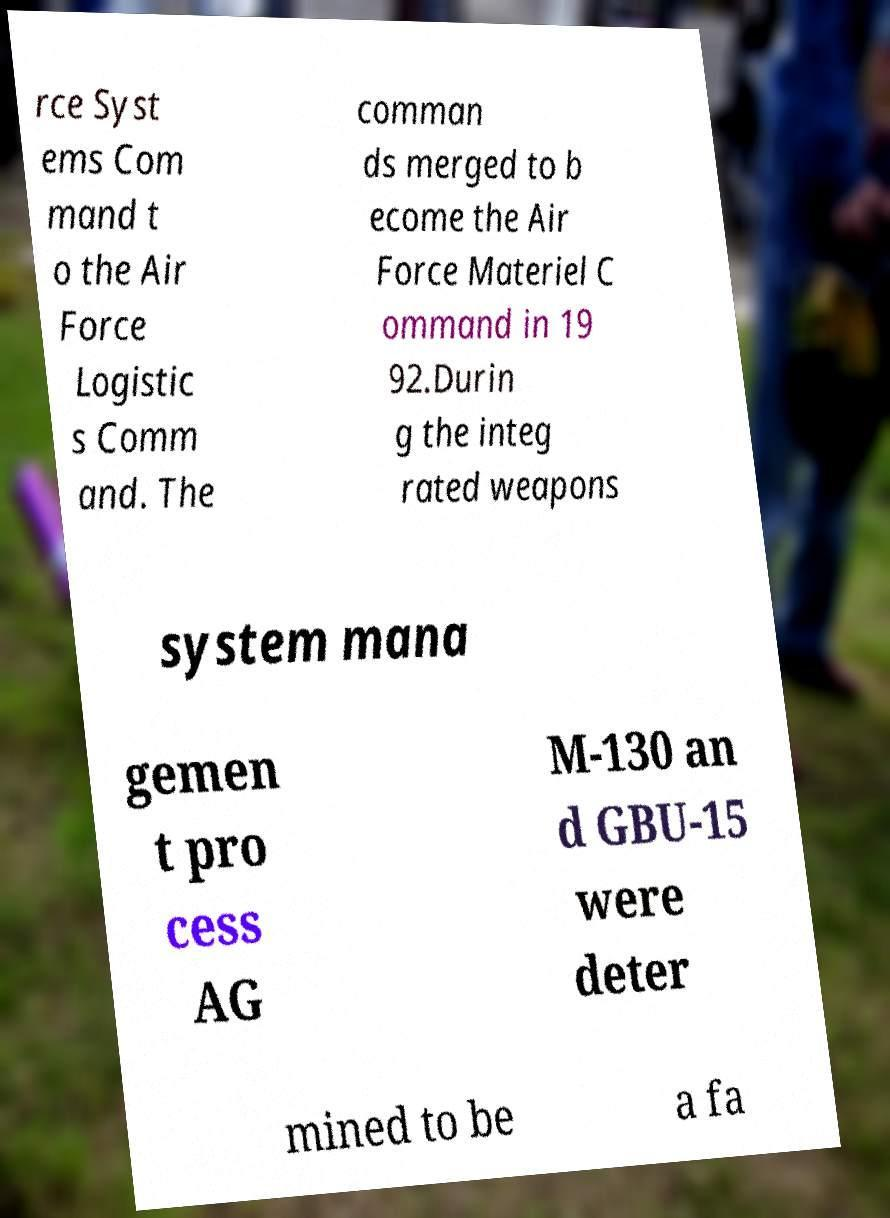Can you read and provide the text displayed in the image?This photo seems to have some interesting text. Can you extract and type it out for me? rce Syst ems Com mand t o the Air Force Logistic s Comm and. The comman ds merged to b ecome the Air Force Materiel C ommand in 19 92.Durin g the integ rated weapons system mana gemen t pro cess AG M-130 an d GBU-15 were deter mined to be a fa 